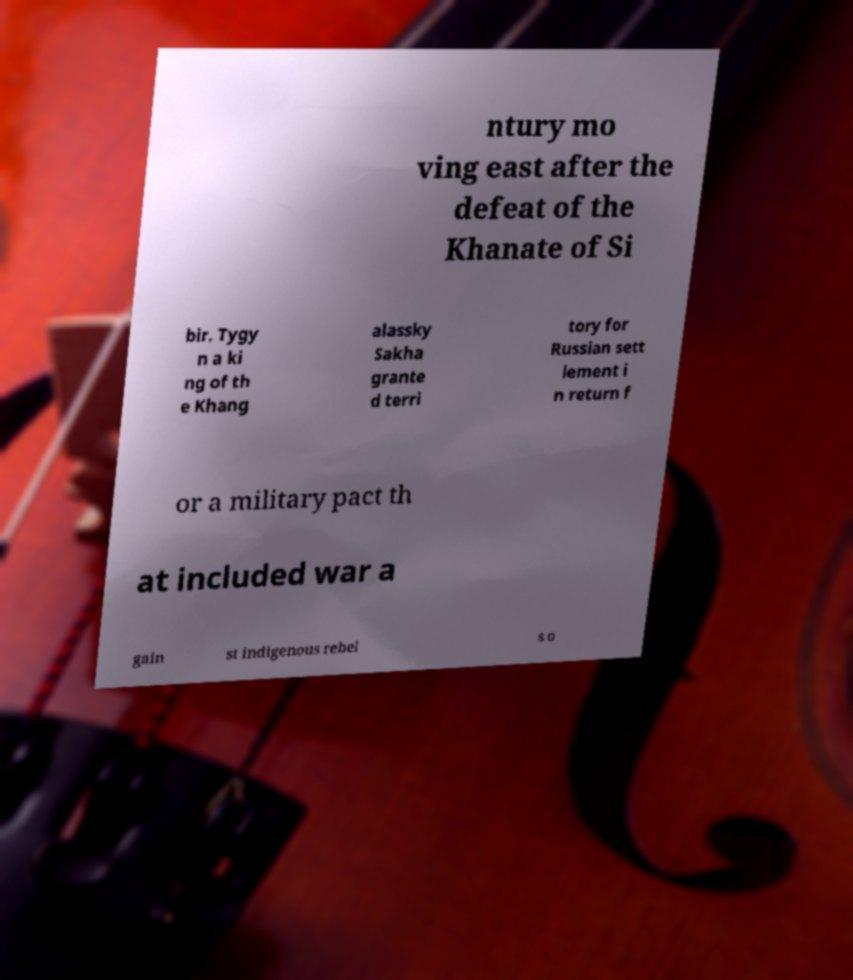Please read and relay the text visible in this image. What does it say? ntury mo ving east after the defeat of the Khanate of Si bir. Tygy n a ki ng of th e Khang alassky Sakha grante d terri tory for Russian sett lement i n return f or a military pact th at included war a gain st indigenous rebel s o 